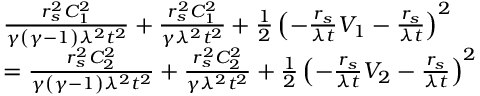Convert formula to latex. <formula><loc_0><loc_0><loc_500><loc_500>\begin{array} { r l } & { \frac { r _ { s } ^ { 2 } C _ { 1 } ^ { 2 } } { \gamma \left ( \gamma - 1 \right ) \lambda ^ { 2 } t ^ { 2 } } + \frac { r _ { s } ^ { 2 } C _ { 1 } ^ { 2 } } { \gamma \lambda ^ { 2 } t ^ { 2 } } + \frac { 1 } { 2 } \left ( - \frac { r _ { s } } { \lambda t } V _ { 1 } - \frac { r _ { s } } { \lambda t } \right ) ^ { 2 } } \\ & { = \frac { r _ { s } ^ { 2 } C _ { 2 } ^ { 2 } } { \gamma \left ( \gamma - 1 \right ) \lambda ^ { 2 } t ^ { 2 } } + \frac { r _ { s } ^ { 2 } C _ { 2 } ^ { 2 } } { \gamma \lambda ^ { 2 } t ^ { 2 } } + \frac { 1 } { 2 } \left ( - \frac { r _ { s } } { \lambda t } V _ { 2 } - \frac { r _ { s } } { \lambda t } \right ) ^ { 2 } } \end{array}</formula> 